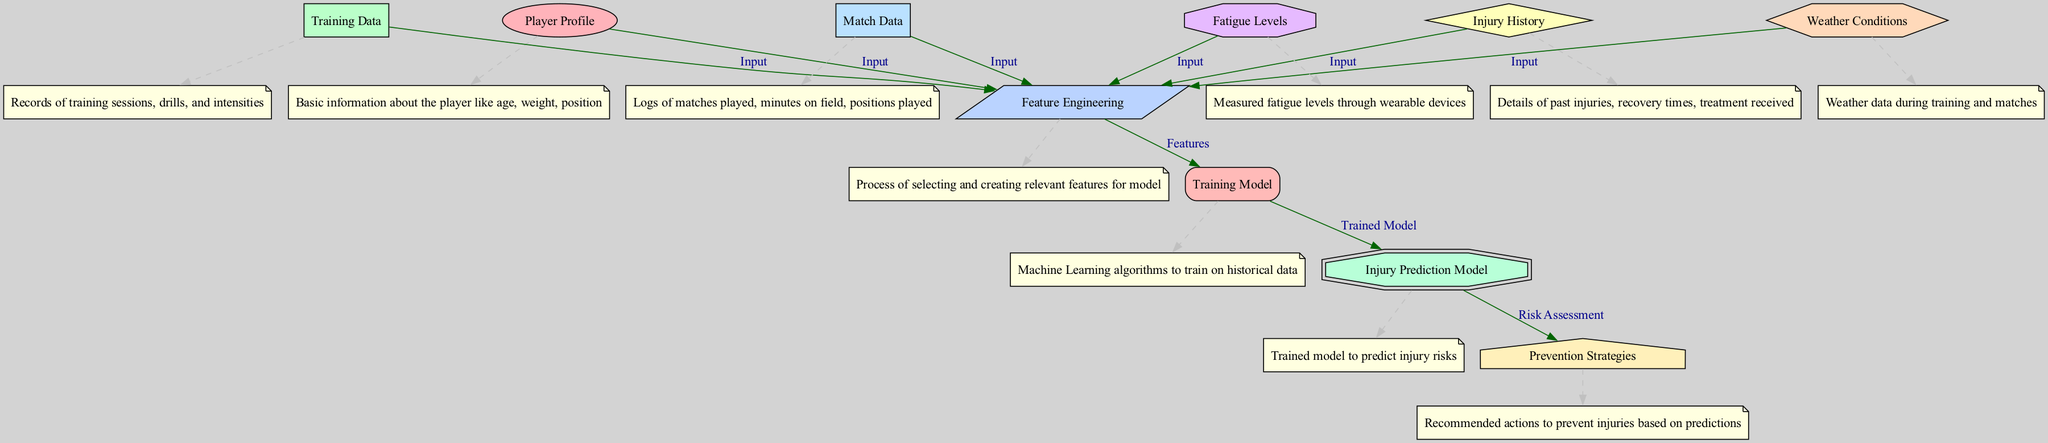What is the first step in the diagram? The first step in the diagram is to gather the inputs from different nodes, specifically player profile, training data, match data, injury history, weather conditions, and fatigue levels, which all feed into feature engineering.
Answer: Feature Engineering How many nodes are present in the diagram? By counting the nodes listed in the diagram, there are a total of ten nodes that represent various components of the injury prediction and prevention process.
Answer: Ten Which node directly connects to the injury prediction model? The node directly connecting to the injury prediction model is the training model, as it consists of the trained algorithm applied to the features from feature engineering.
Answer: Training Model What is the purpose of the prevention strategies node? The prevention strategies node is designed to provide recommended actions to avert injuries based on the risk assessment generated from the injury prediction model.
Answer: Recommended actions What type of data is used in the feature engineering process? The feature engineering process utilizes various types of data as inputs, including player profiles, training data, match data, injury history, weather conditions, and fatigue levels to create relevant features for the model.
Answer: Various data types What shape is used to represent injury history? The injury history is represented using a diamond shape in the diagram, which indicates that it is a significant or critical factor in the injury prediction process.
Answer: Diamond How does the injury prediction model utilize prior data? The injury prediction model uses prior data by being trained on historical data derived from feature engineering, which incorporates insights from match data, training data, and injury history to assess injury risks.
Answer: Historical data Which node receives outputs from the injury prediction model? The node that receives outputs from the injury prediction model is the prevention strategies node, as it takes the injury risk assessment to formulate actions that can prevent injuries.
Answer: Prevention Strategies What is the function of fatigue levels in the diagram? Fatigue levels serve as an input in the diagram that is measured through wearable devices, contributing to the overall assessment of player conditions for feature engineering.
Answer: Measured input How does the model assess injury risks? The model assesses injury risks by being trained on features derived from various inputs, enabling it to identify patterns and predict potential injuries based on historical performance and conditions.
Answer: Patterns and predictions 